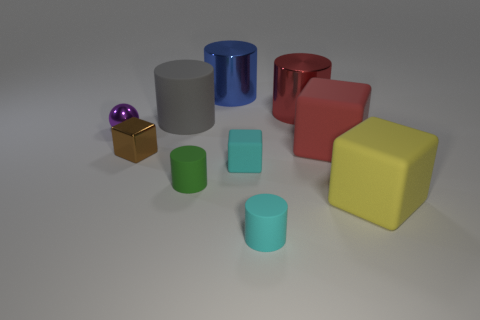Subtract all cyan cylinders. How many cylinders are left? 4 Subtract all red cylinders. How many cylinders are left? 4 Subtract all yellow cylinders. Subtract all red balls. How many cylinders are left? 5 Subtract 0 gray spheres. How many objects are left? 10 Subtract all spheres. How many objects are left? 9 Subtract all red metal cylinders. Subtract all large blocks. How many objects are left? 7 Add 7 yellow blocks. How many yellow blocks are left? 8 Add 3 large cyan objects. How many large cyan objects exist? 3 